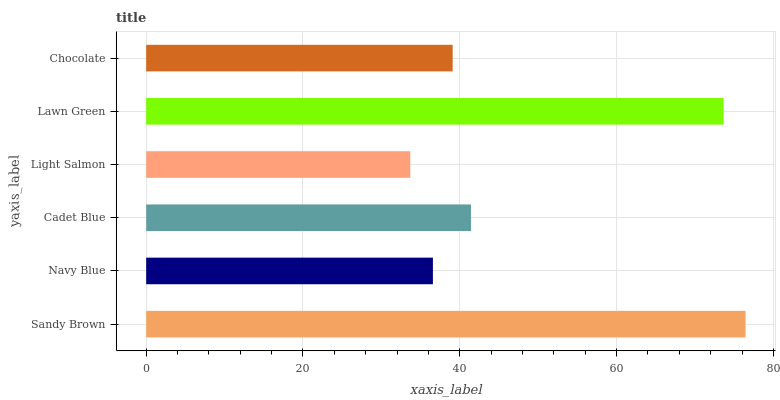Is Light Salmon the minimum?
Answer yes or no. Yes. Is Sandy Brown the maximum?
Answer yes or no. Yes. Is Navy Blue the minimum?
Answer yes or no. No. Is Navy Blue the maximum?
Answer yes or no. No. Is Sandy Brown greater than Navy Blue?
Answer yes or no. Yes. Is Navy Blue less than Sandy Brown?
Answer yes or no. Yes. Is Navy Blue greater than Sandy Brown?
Answer yes or no. No. Is Sandy Brown less than Navy Blue?
Answer yes or no. No. Is Cadet Blue the high median?
Answer yes or no. Yes. Is Chocolate the low median?
Answer yes or no. Yes. Is Chocolate the high median?
Answer yes or no. No. Is Sandy Brown the low median?
Answer yes or no. No. 